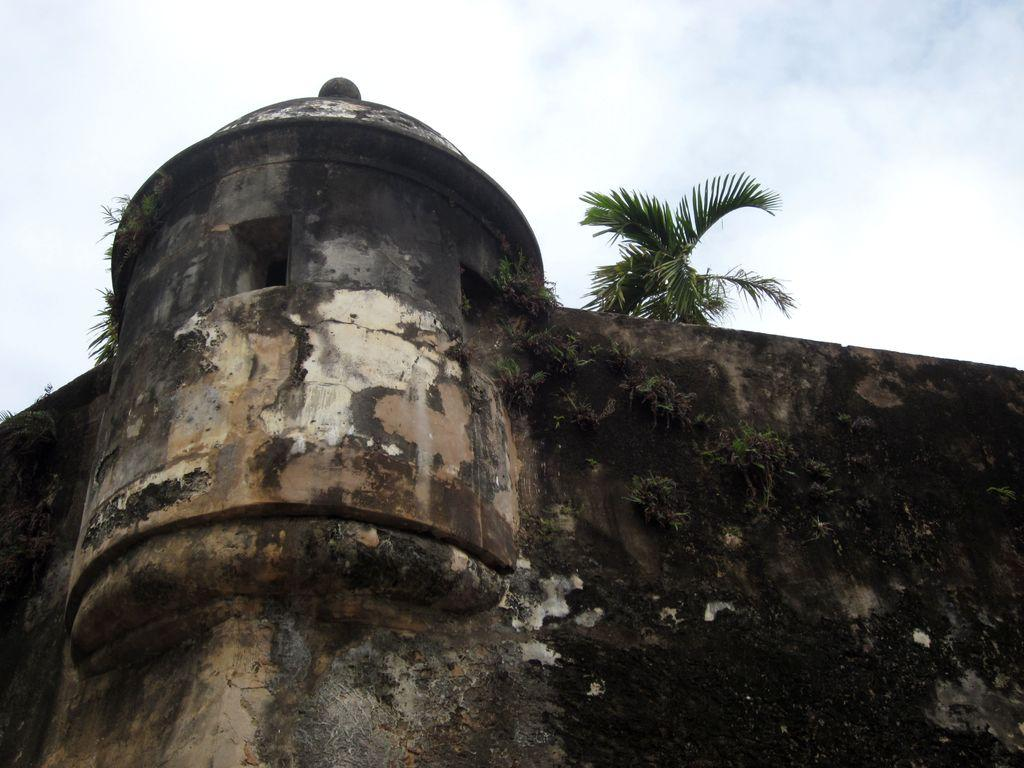What type of structure is visible in the image? There is a building in the image. What can be seen behind the wall in the image? There are trees behind the wall in the image. What is growing on the wall in the image? There are plants on the wall in the image. What is visible at the top of the image? The sky is visible at the top of the image. What can be observed in the sky? There are clouds in the sky. How many friends are playing with balls in the image? There are no friends or balls present in the image. What type of oven is visible in the image? There is no oven present in the image. 